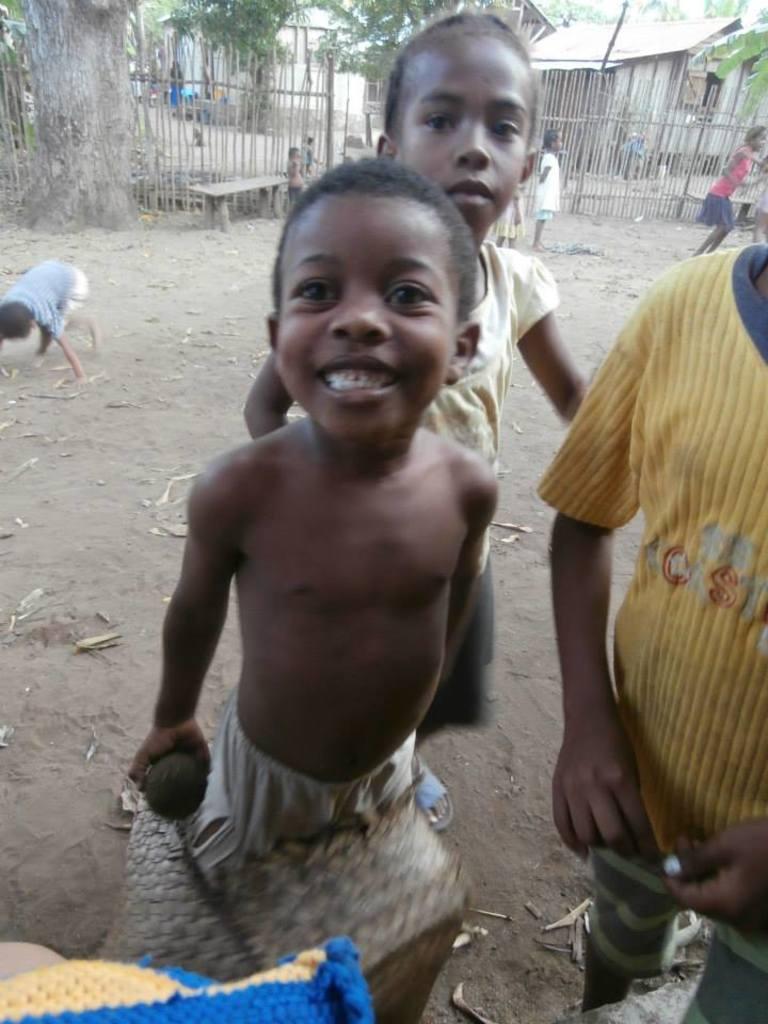Could you give a brief overview of what you see in this image? In this image there are a few people standing and playing on the surface, one of them is holding an object, in the background there is a wooden fence, trees and houses. 